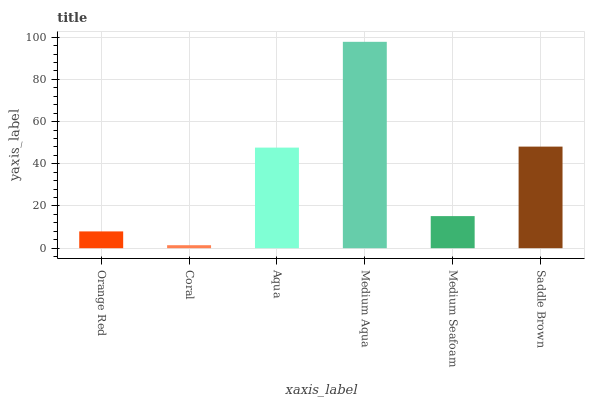Is Coral the minimum?
Answer yes or no. Yes. Is Medium Aqua the maximum?
Answer yes or no. Yes. Is Aqua the minimum?
Answer yes or no. No. Is Aqua the maximum?
Answer yes or no. No. Is Aqua greater than Coral?
Answer yes or no. Yes. Is Coral less than Aqua?
Answer yes or no. Yes. Is Coral greater than Aqua?
Answer yes or no. No. Is Aqua less than Coral?
Answer yes or no. No. Is Aqua the high median?
Answer yes or no. Yes. Is Medium Seafoam the low median?
Answer yes or no. Yes. Is Medium Seafoam the high median?
Answer yes or no. No. Is Coral the low median?
Answer yes or no. No. 